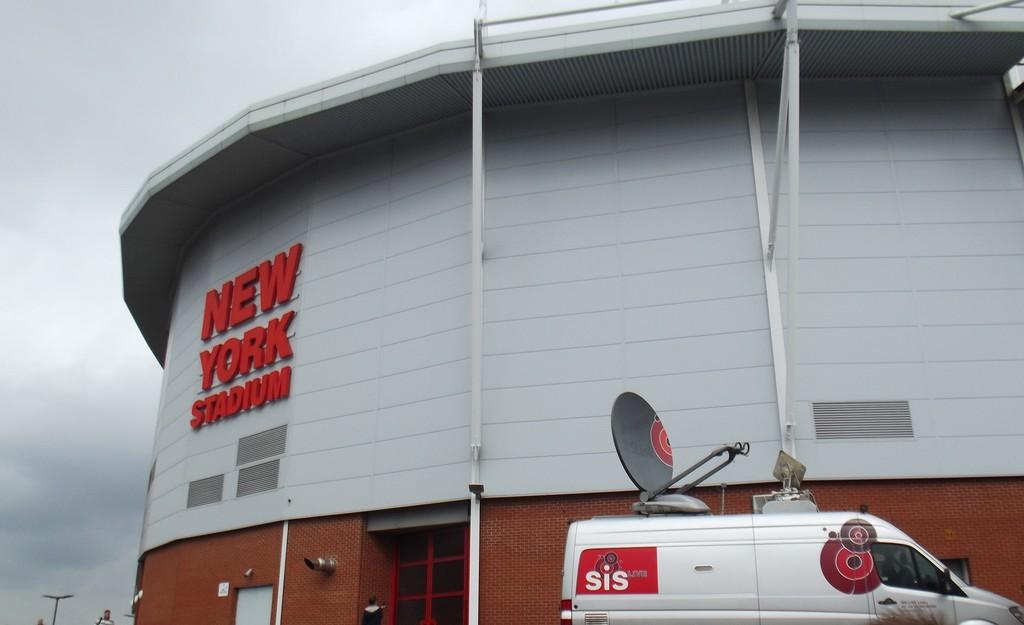<image>
Write a terse but informative summary of the picture. A white van is parked outside the "New York Stadium." 